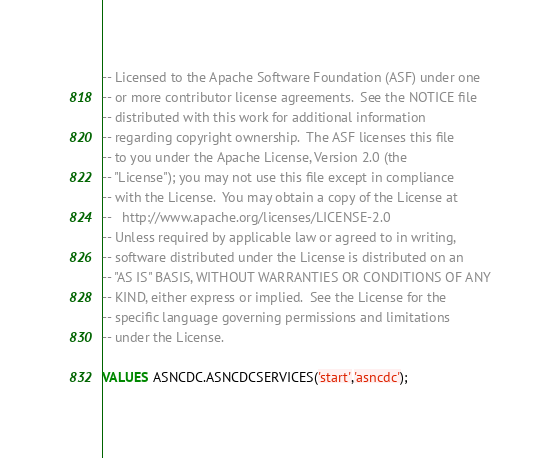Convert code to text. <code><loc_0><loc_0><loc_500><loc_500><_SQL_>-- Licensed to the Apache Software Foundation (ASF) under one
-- or more contributor license agreements.  See the NOTICE file
-- distributed with this work for additional information
-- regarding copyright ownership.  The ASF licenses this file
-- to you under the Apache License, Version 2.0 (the
-- "License"); you may not use this file except in compliance
-- with the License.  You may obtain a copy of the License at
--   http://www.apache.org/licenses/LICENSE-2.0
-- Unless required by applicable law or agreed to in writing,
-- software distributed under the License is distributed on an
-- "AS IS" BASIS, WITHOUT WARRANTIES OR CONDITIONS OF ANY
-- KIND, either express or implied.  See the License for the
-- specific language governing permissions and limitations
-- under the License.

VALUES ASNCDC.ASNCDCSERVICES('start','asncdc');
</code> 